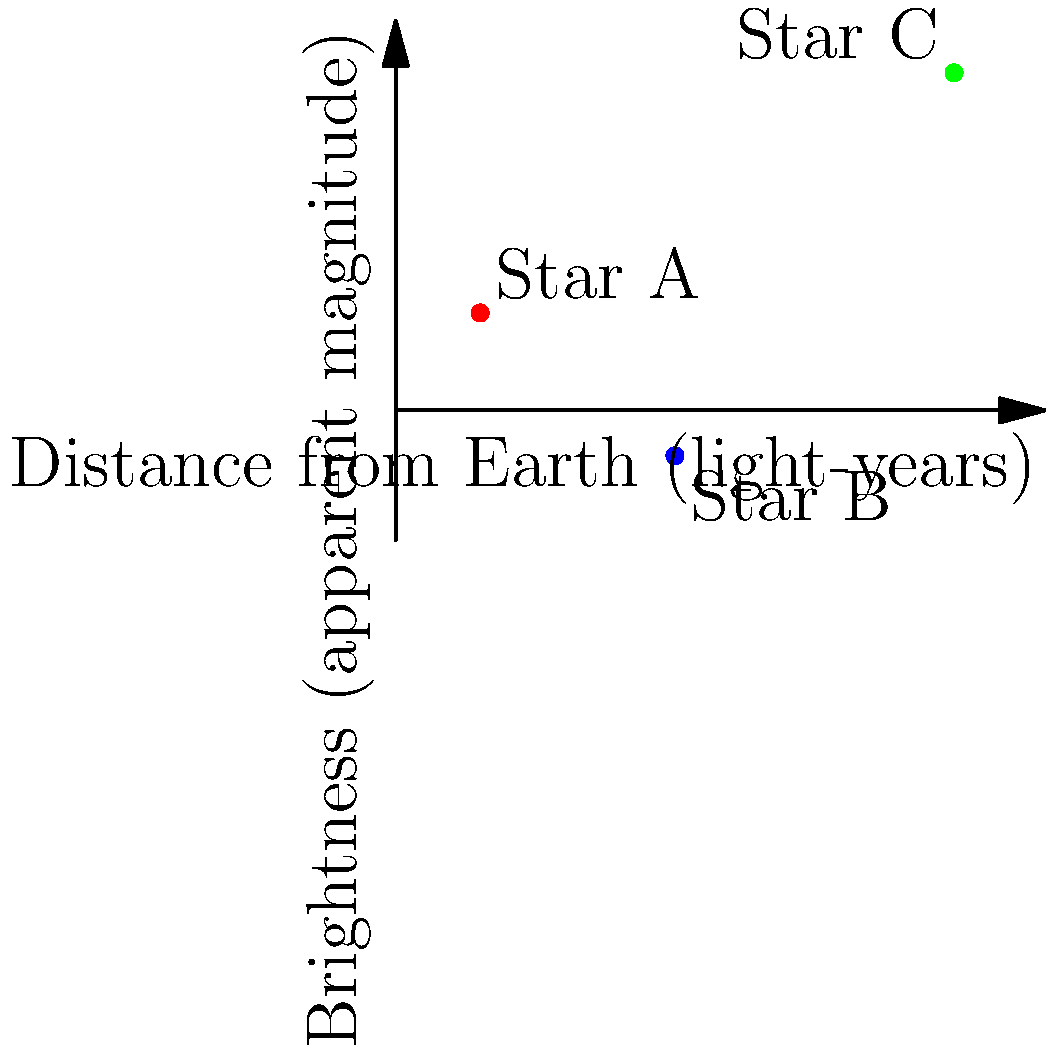In the scatter plot above, three stars (A, B, and C) are shown with their distances from Earth and apparent brightness. Which star is likely to be the most intrinsically luminous? To determine which star is likely the most intrinsically luminous, we need to consider both the distance and apparent brightness of each star. Let's analyze the information step-by-step:

1. Recall that apparent magnitude (brightness) is inversely related to actual brightness. Lower numbers indicate brighter stars.

2. Star A:
   - Distance: ~1.3 light-years
   - Apparent magnitude: ~1.5

3. Star B:
   - Distance: ~4.3 light-years
   - Apparent magnitude: ~-0.7

4. Star C:
   - Distance: ~8.6 light-years
   - Apparent magnitude: ~5.2

5. Star B appears brightest (lowest magnitude) despite being farther away than Star A. This suggests it's more luminous than Star A.

6. Star C is the farthest and appears the dimmest. However, its great distance means it could still be very luminous.

7. To compare intrinsic luminosity, we need to consider how bright each star would appear at the same distance.

8. If we mentally move Stars A and C to the same distance as Star B:
   - Star A would appear much dimmer
   - Star C would appear much brighter

9. Therefore, Star C is likely the most intrinsically luminous, as it manages to still be visible despite its great distance.

This analysis is similar to how astronomers during World War II might have used star charts to navigate, considering both apparent brightness and known distances to determine a star's true nature.
Answer: Star C 